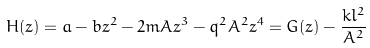Convert formula to latex. <formula><loc_0><loc_0><loc_500><loc_500>H ( z ) = a - b z ^ { 2 } - 2 m A z ^ { 3 } - q ^ { 2 } A ^ { 2 } z ^ { 4 } = G ( z ) - \frac { k l ^ { 2 } } { A ^ { 2 } }</formula> 